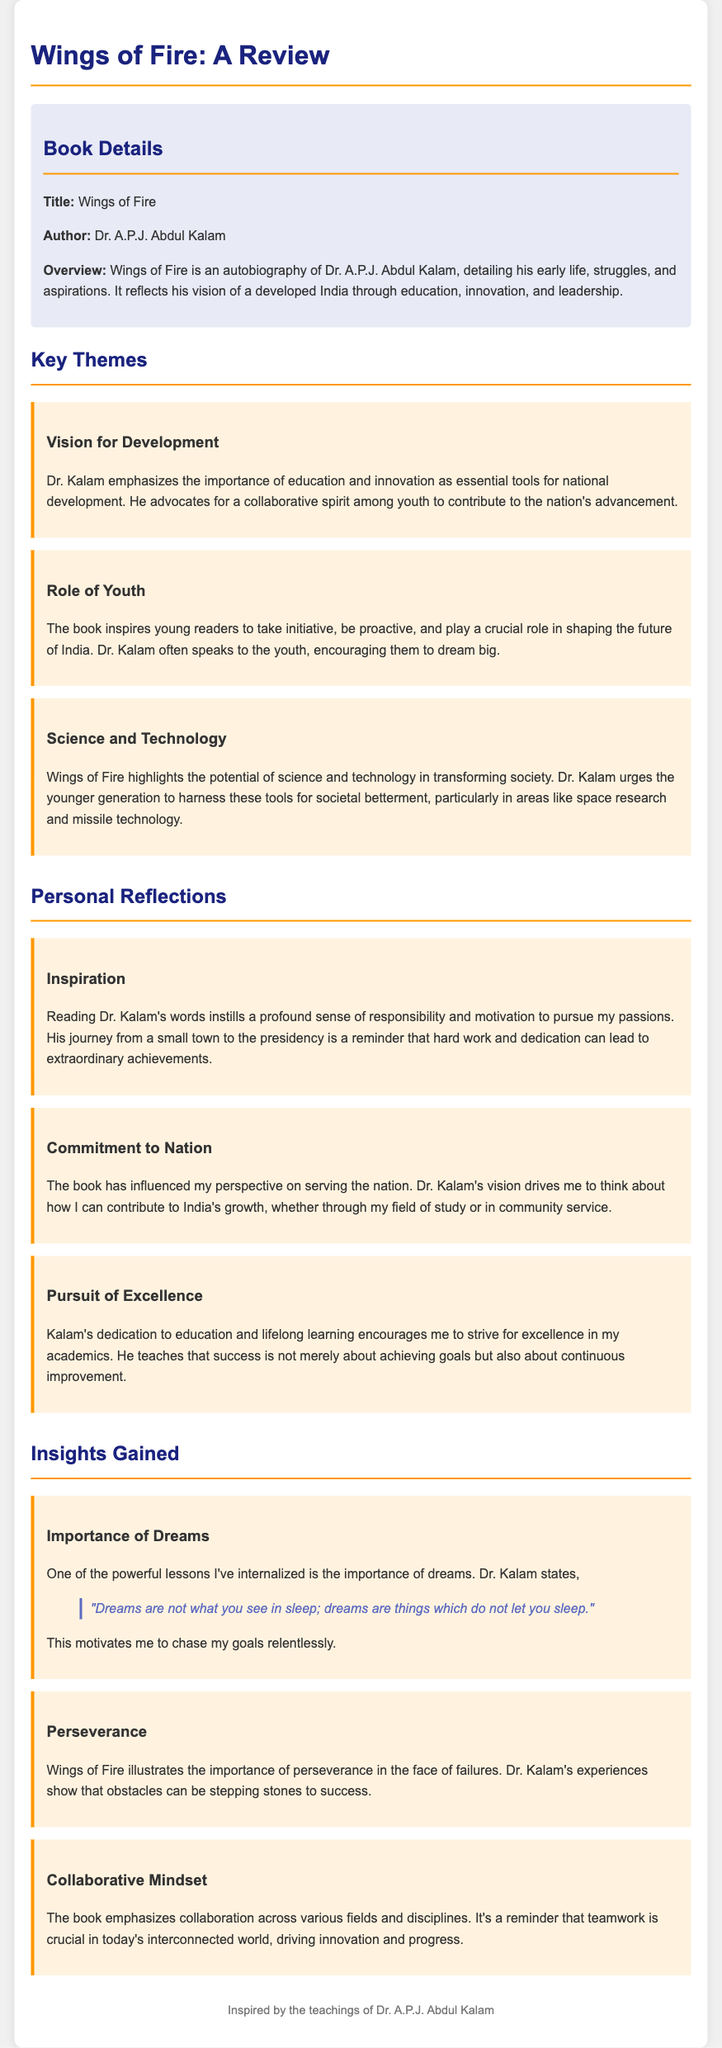What is the title of the book? The title of the book is explicitly stated in the document as "Wings of Fire."
Answer: Wings of Fire Who is the author of the book? The author is mentioned in the book details section as Dr. A.P.J. Abdul Kalam.
Answer: Dr. A.P.J. Abdul Kalam What is one of the key themes discussed in the book? The key themes such as "Vision for Development" are highlighted in the themes section of the document.
Answer: Vision for Development According to the review, what does Dr. Kalam encourage the youth to do? The document states that Dr. Kalam inspires young readers to take initiative and dream big.
Answer: Dream big What powerful lesson is mentioned regarding dreams? The lesson states that "Dreams are not what you see in sleep; dreams are things which do not let you sleep."
Answer: Dreams are things which do not let you sleep What does the review suggest about the role of science and technology? The book emphasizes the potential of science and technology in transforming society, as noted in the themes section.
Answer: Transforming society Name one personal reflection the author gained from the book. The author specifically mentions "Inspiration" as one of the personal reflections gained from reading the book.
Answer: Inspiration What does the document highlight as crucial in today’s interconnected world? The importance of a "Collaborative Mindset" is emphasized in the insights gained section.
Answer: Collaborative Mindset How does Dr. Kalam's journey inspire the author of the review? The review reflects that Dr. Kalam's journey from a small town to the presidency reminds the author that hard work leads to extraordinary achievements.
Answer: Hard work leads to extraordinary achievements 